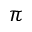<formula> <loc_0><loc_0><loc_500><loc_500>\pi</formula> 